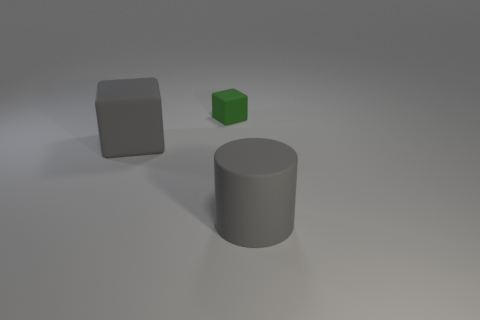Are there more small red rubber cylinders than matte objects?
Give a very brief answer. No. The green object has what size?
Provide a short and direct response. Small. How many other things are the same color as the large cylinder?
Your response must be concise. 1. Are the cube that is in front of the small cube and the tiny thing made of the same material?
Your response must be concise. Yes. Are there fewer large gray rubber objects that are behind the large cylinder than things that are to the right of the large gray cube?
Your response must be concise. Yes. There is a object that is the same size as the gray matte cylinder; what is its material?
Offer a very short reply. Rubber. Is the number of green matte things behind the green rubber cube less than the number of tiny brown objects?
Give a very brief answer. No. There is a big object to the right of the big rubber thing left of the big gray rubber thing that is in front of the large rubber block; what is its shape?
Give a very brief answer. Cylinder. There is a gray rubber thing that is behind the gray matte cylinder; what size is it?
Your response must be concise. Large. There is a gray thing that is the same size as the gray cube; what shape is it?
Provide a short and direct response. Cylinder. 